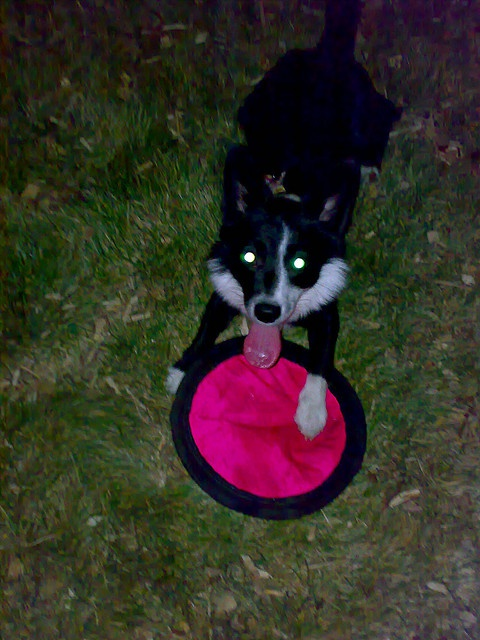Describe the objects in this image and their specific colors. I can see dog in black and gray tones and frisbee in black, brown, and purple tones in this image. 